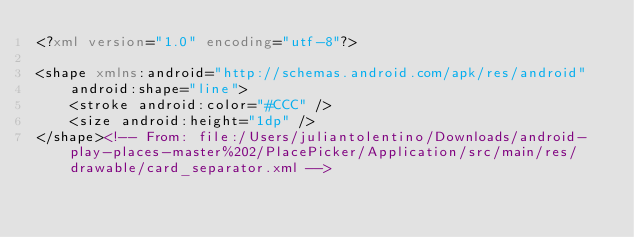<code> <loc_0><loc_0><loc_500><loc_500><_XML_><?xml version="1.0" encoding="utf-8"?>

<shape xmlns:android="http://schemas.android.com/apk/res/android"
    android:shape="line">
    <stroke android:color="#CCC" />
    <size android:height="1dp" />
</shape><!-- From: file:/Users/juliantolentino/Downloads/android-play-places-master%202/PlacePicker/Application/src/main/res/drawable/card_separator.xml --></code> 